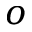Convert formula to latex. <formula><loc_0><loc_0><loc_500><loc_500>o</formula> 